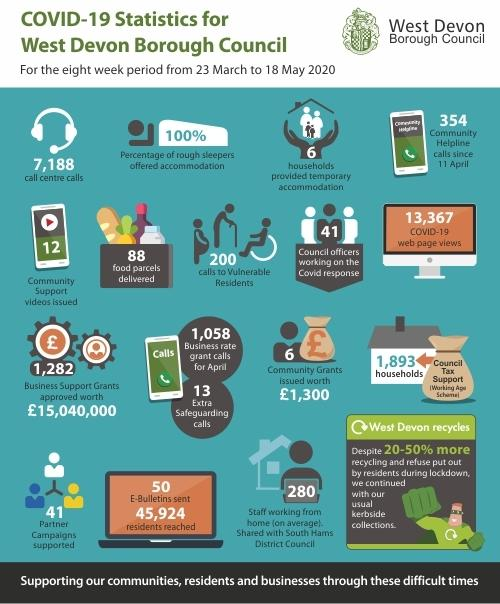Identify some key points in this picture. From March 23 to May 18, 2020, the West Devon Borough Council delivered 88 food parcels as part of its Covid-19 response work. The West Devon Borough Council issued 12 community support videos as part of its Covid-19 response work from March 23 to May 18, 2020. Between March 23 and May 18, 2020, the West Devon Borough Council made 200 calls to vulnerable individuals as part of its Covid-19 response work. From March 23 to May 18, 2020, the West Devon Borough Council provided temporary accommodation to a total of 6 households as part of its response to the Covid-19 pandemic. In the period from March 23 to May 18, 2020, a total of 41 council officers were dedicated to handling the COVID-19 response. 